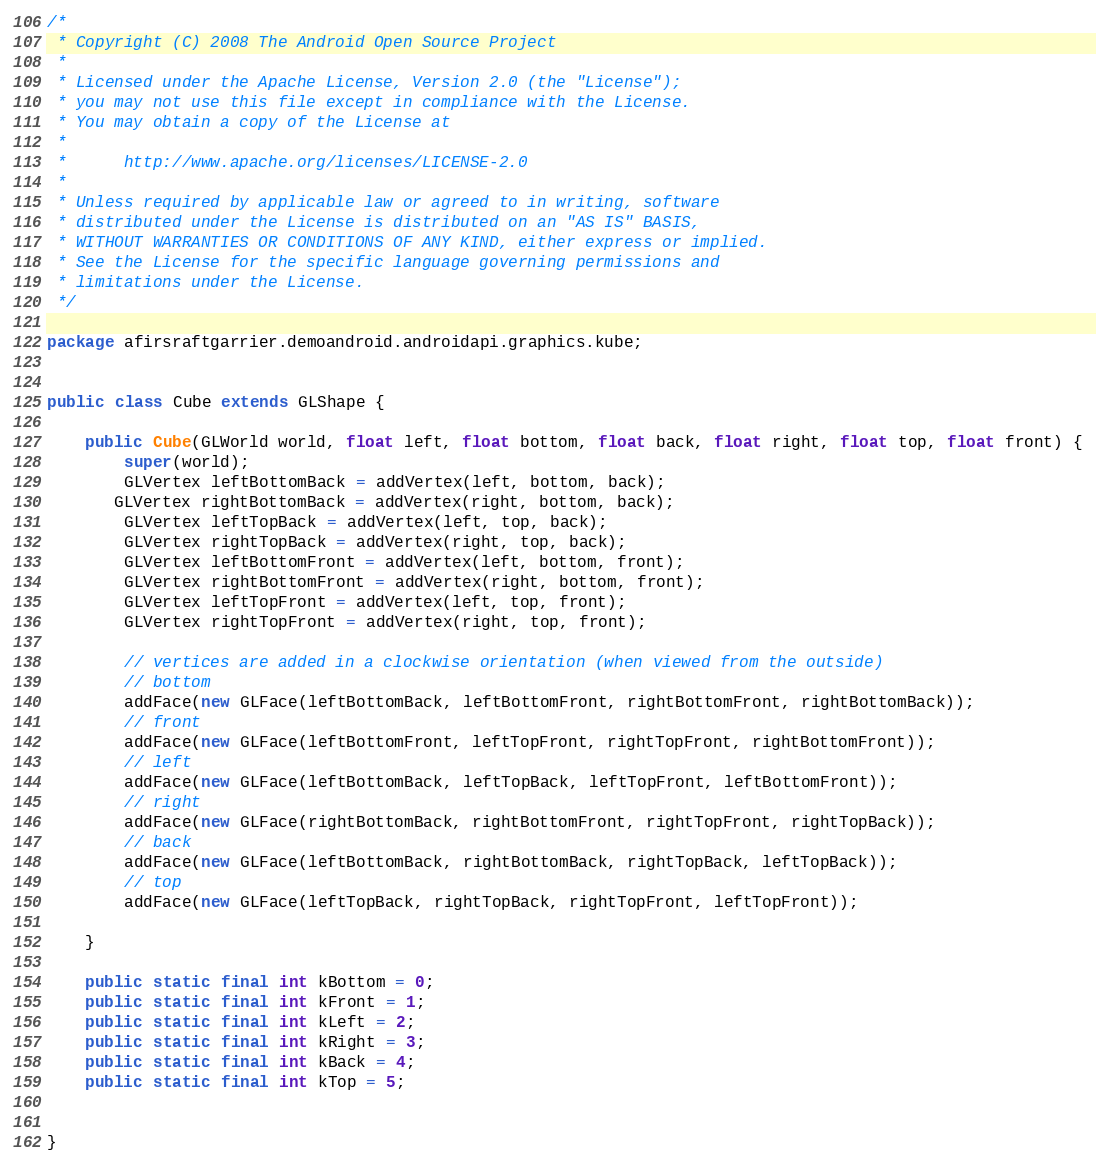<code> <loc_0><loc_0><loc_500><loc_500><_Java_>/*
 * Copyright (C) 2008 The Android Open Source Project
 *
 * Licensed under the Apache License, Version 2.0 (the "License");
 * you may not use this file except in compliance with the License.
 * You may obtain a copy of the License at
 *
 *      http://www.apache.org/licenses/LICENSE-2.0
 *
 * Unless required by applicable law or agreed to in writing, software
 * distributed under the License is distributed on an "AS IS" BASIS,
 * WITHOUT WARRANTIES OR CONDITIONS OF ANY KIND, either express or implied.
 * See the License for the specific language governing permissions and
 * limitations under the License.
 */

package afirsraftgarrier.demoandroid.androidapi.graphics.kube;


public class Cube extends GLShape {

	public Cube(GLWorld world, float left, float bottom, float back, float right, float top, float front) {
		super(world);
       	GLVertex leftBottomBack = addVertex(left, bottom, back);
       GLVertex rightBottomBack = addVertex(right, bottom, back);
       	GLVertex leftTopBack = addVertex(left, top, back);
        GLVertex rightTopBack = addVertex(right, top, back);
       	GLVertex leftBottomFront = addVertex(left, bottom, front);
        GLVertex rightBottomFront = addVertex(right, bottom, front);
       	GLVertex leftTopFront = addVertex(left, top, front);
        GLVertex rightTopFront = addVertex(right, top, front);

        // vertices are added in a clockwise orientation (when viewed from the outside)
        // bottom
        addFace(new GLFace(leftBottomBack, leftBottomFront, rightBottomFront, rightBottomBack));
        // front
        addFace(new GLFace(leftBottomFront, leftTopFront, rightTopFront, rightBottomFront));
        // left
        addFace(new GLFace(leftBottomBack, leftTopBack, leftTopFront, leftBottomFront));
        // right
        addFace(new GLFace(rightBottomBack, rightBottomFront, rightTopFront, rightTopBack));
        // back
        addFace(new GLFace(leftBottomBack, rightBottomBack, rightTopBack, leftTopBack));
        // top
        addFace(new GLFace(leftTopBack, rightTopBack, rightTopFront, leftTopFront));
		
	}
	
    public static final int kBottom = 0;
    public static final int kFront = 1;
    public static final int kLeft = 2;
    public static final int kRight = 3;
    public static final int kBack = 4;
    public static final int kTop = 5;

	
}
</code> 